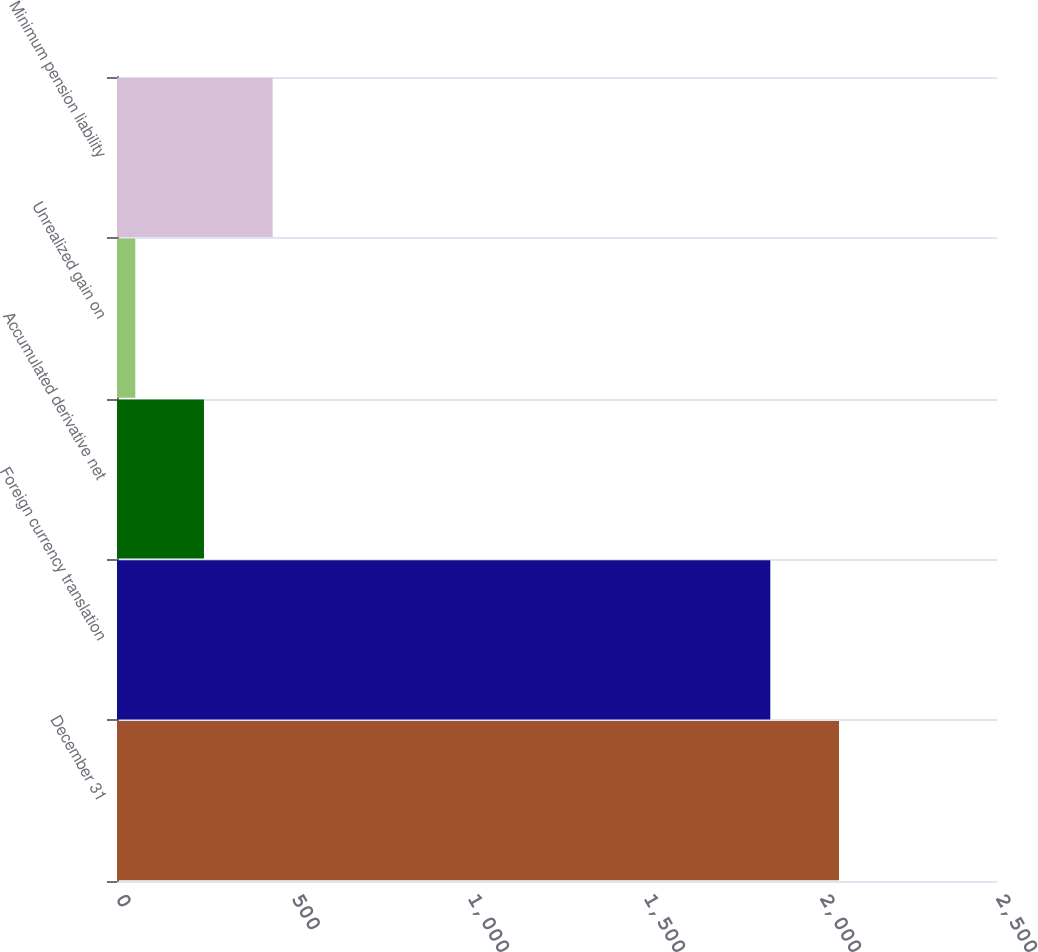<chart> <loc_0><loc_0><loc_500><loc_500><bar_chart><fcel>December 31<fcel>Foreign currency translation<fcel>Accumulated derivative net<fcel>Unrealized gain on<fcel>Minimum pension liability<nl><fcel>2051.1<fcel>1856<fcel>247.1<fcel>52<fcel>442.2<nl></chart> 